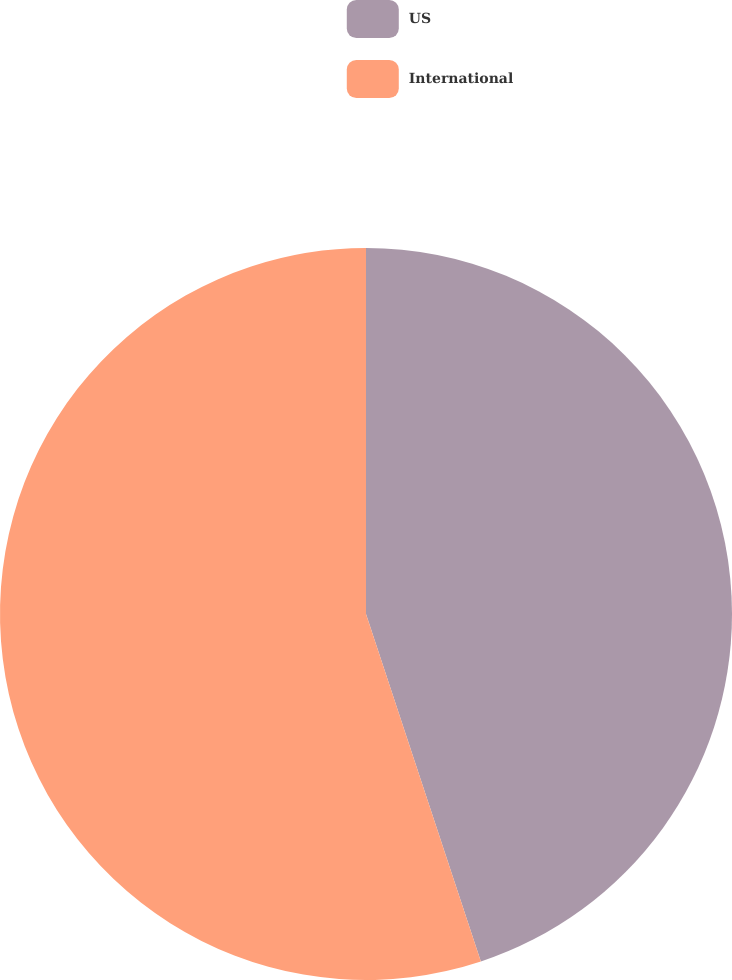<chart> <loc_0><loc_0><loc_500><loc_500><pie_chart><fcel>US<fcel>International<nl><fcel>44.92%<fcel>55.08%<nl></chart> 